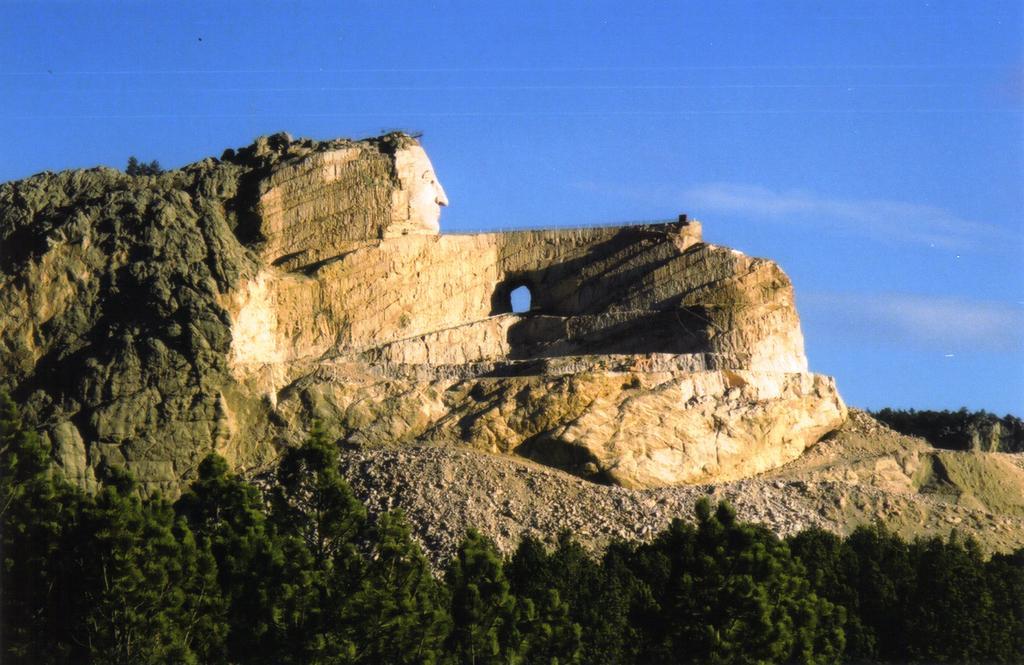How would you summarize this image in a sentence or two? This image is taken outdoors. At the top of the image there is the sky with clouds. At the bottom of the image there are many trees with leaves, stems and branches. In the background there are a few trees. In the middle of the image there is a big rock and there is a carving of a human face on the rock. 